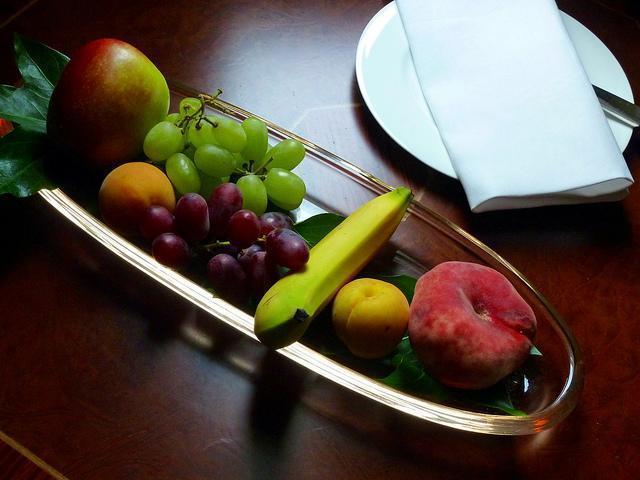Evaluate: Does the caption "The dining table is touching the apple." match the image?
Answer yes or no. No. 